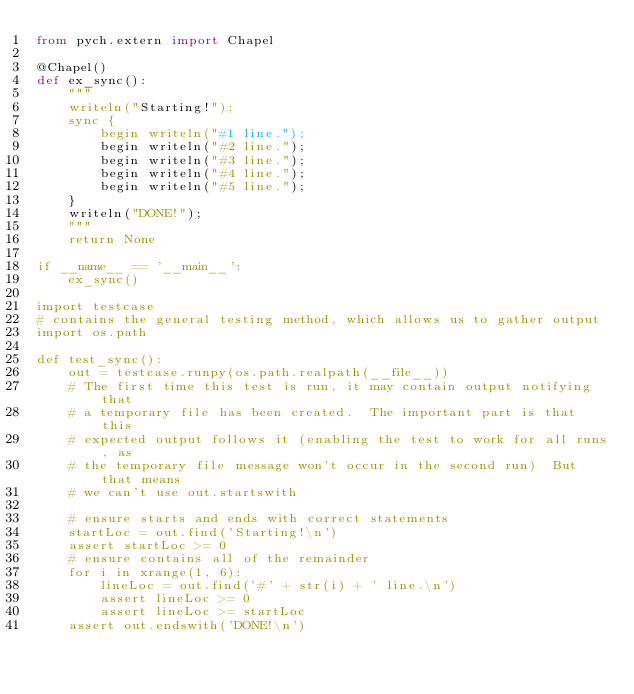Convert code to text. <code><loc_0><loc_0><loc_500><loc_500><_Python_>from pych.extern import Chapel

@Chapel()
def ex_sync():
    """
    writeln("Starting!");
    sync {
        begin writeln("#1 line.");
        begin writeln("#2 line.");
        begin writeln("#3 line.");
        begin writeln("#4 line.");
        begin writeln("#5 line.");
    }
    writeln("DONE!");
    """
    return None

if __name__ == '__main__':
    ex_sync()

import testcase
# contains the general testing method, which allows us to gather output
import os.path

def test_sync():
    out = testcase.runpy(os.path.realpath(__file__))
    # The first time this test is run, it may contain output notifying that
    # a temporary file has been created.  The important part is that this
    # expected output follows it (enabling the test to work for all runs, as
    # the temporary file message won't occur in the second run)  But that means
    # we can't use out.startswith

    # ensure starts and ends with correct statements
    startLoc = out.find('Starting!\n')
    assert startLoc >= 0
    # ensure contains all of the remainder
    for i in xrange(1, 6):
        lineLoc = out.find('#' + str(i) + ' line.\n')
        assert lineLoc >= 0
        assert lineLoc >= startLoc
    assert out.endswith('DONE!\n')
</code> 